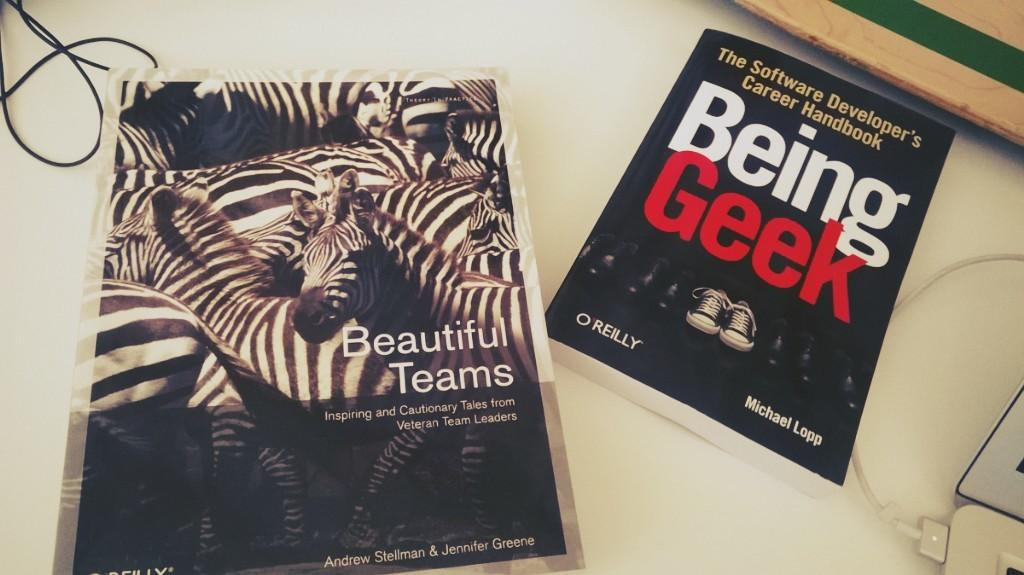<image>
Share a concise interpretation of the image provided. a book that has the title of Being Geek 